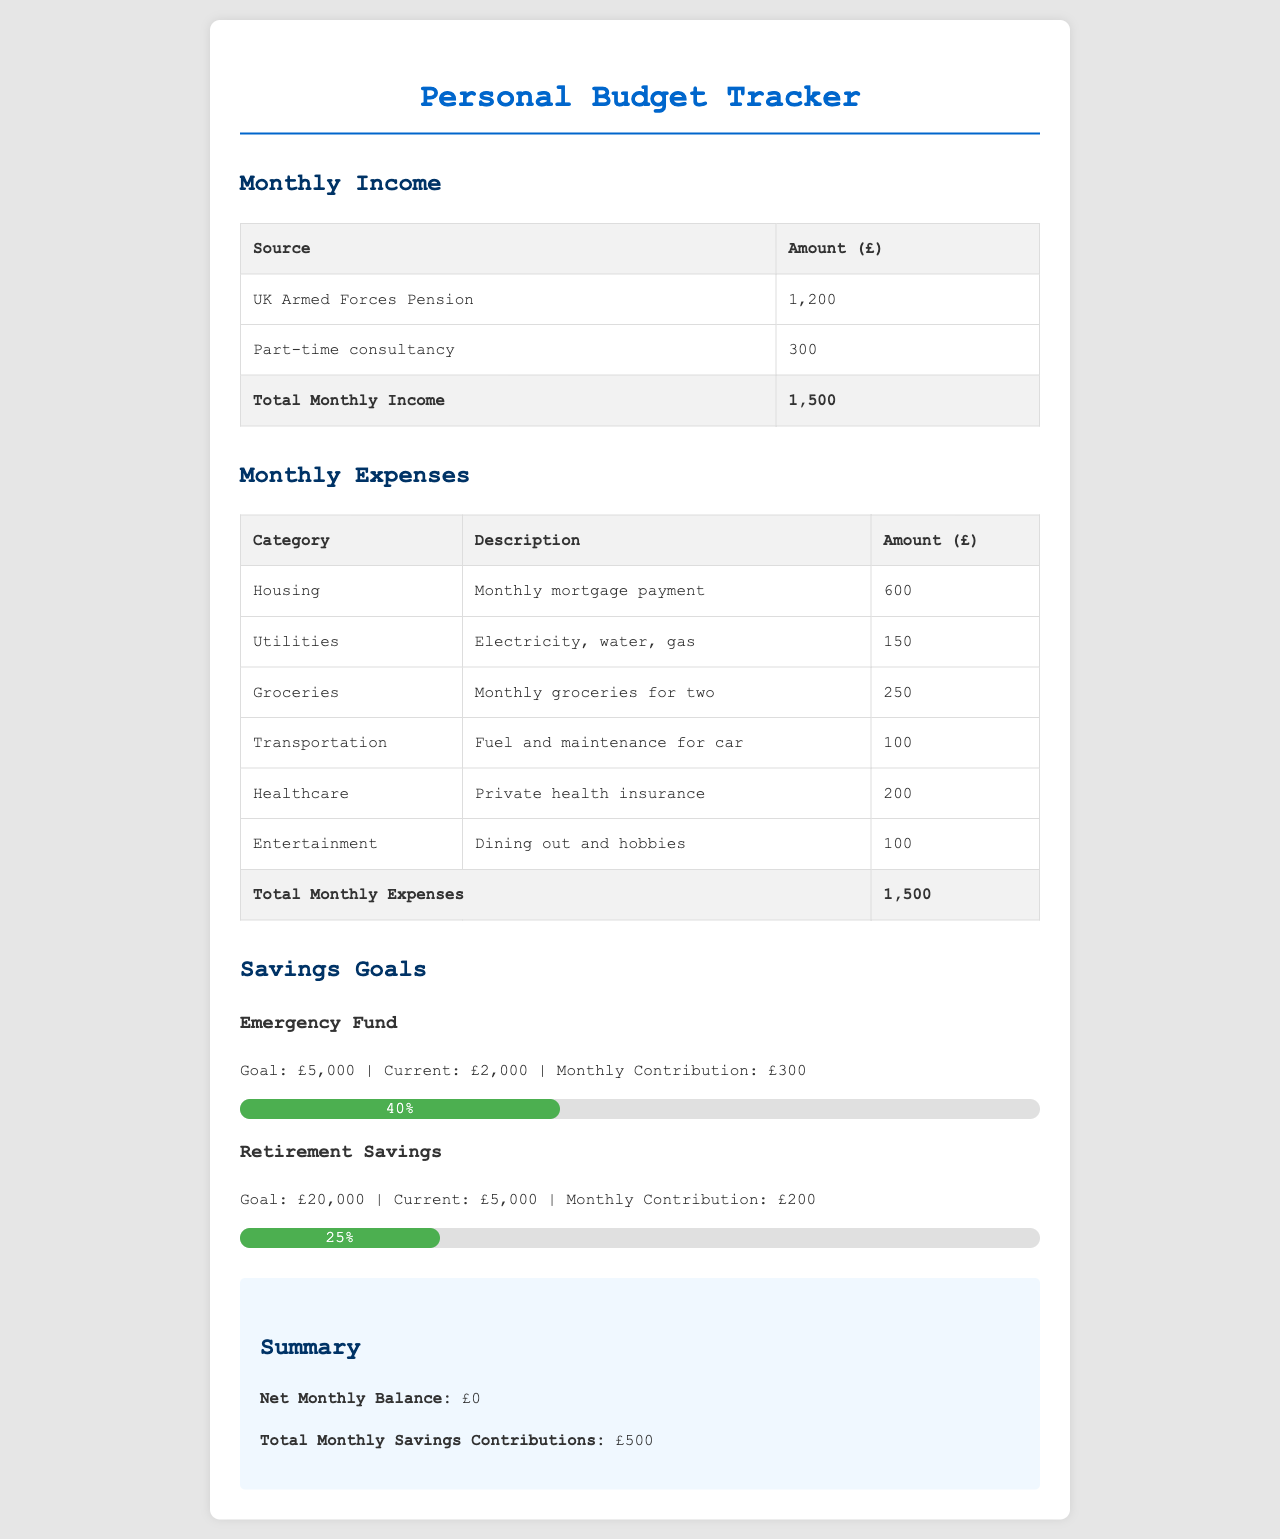What is the total monthly income? The total monthly income is provided at the bottom of the income table, which includes the contributions from both the pension and consultancy.
Answer: 1,500 What is the amount allocated for groceries? The grocery expense is detailed in the expenses table, indicating the monthly expenditure for food.
Answer: 250 How much is the current emergency fund? The current balance for the emergency fund is stated alongside its savings goal and monthly contribution.
Answer: 2,000 What percentage of the retirement savings goal has been achieved? The progress bar indicates the percentage of the savings goal for retirement that has currently been met.
Answer: 25% What is the total amount for monthly expenses? The total monthly expenses are listed at the end of the expenses table, summarizing all expenditures.
Answer: 1,500 How much is contributed monthly to the emergency fund? The monthly contribution towards the emergency fund is specified clearly in the savings goals section.
Answer: 300 What is the goal for retirement savings? The retirement savings goal is mentioned in the savings goals section along with the current savings and monthly contributions.
Answer: 20,000 What is the net monthly balance? The net monthly balance is found in the summary section, reflecting the difference between income and expenses plus savings contributions.
Answer: 0 What is the total amount of monthly savings contributions? This total is shown in the summary section, indicating how much is put away for savings each month.
Answer: 500 